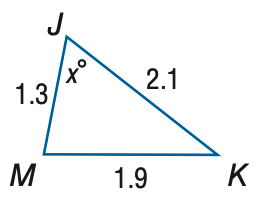Answer the mathemtical geometry problem and directly provide the correct option letter.
Question: Find x. Round to the nearest degree.
Choices: A: 43 B: 53 C: 63 D: 73 C 